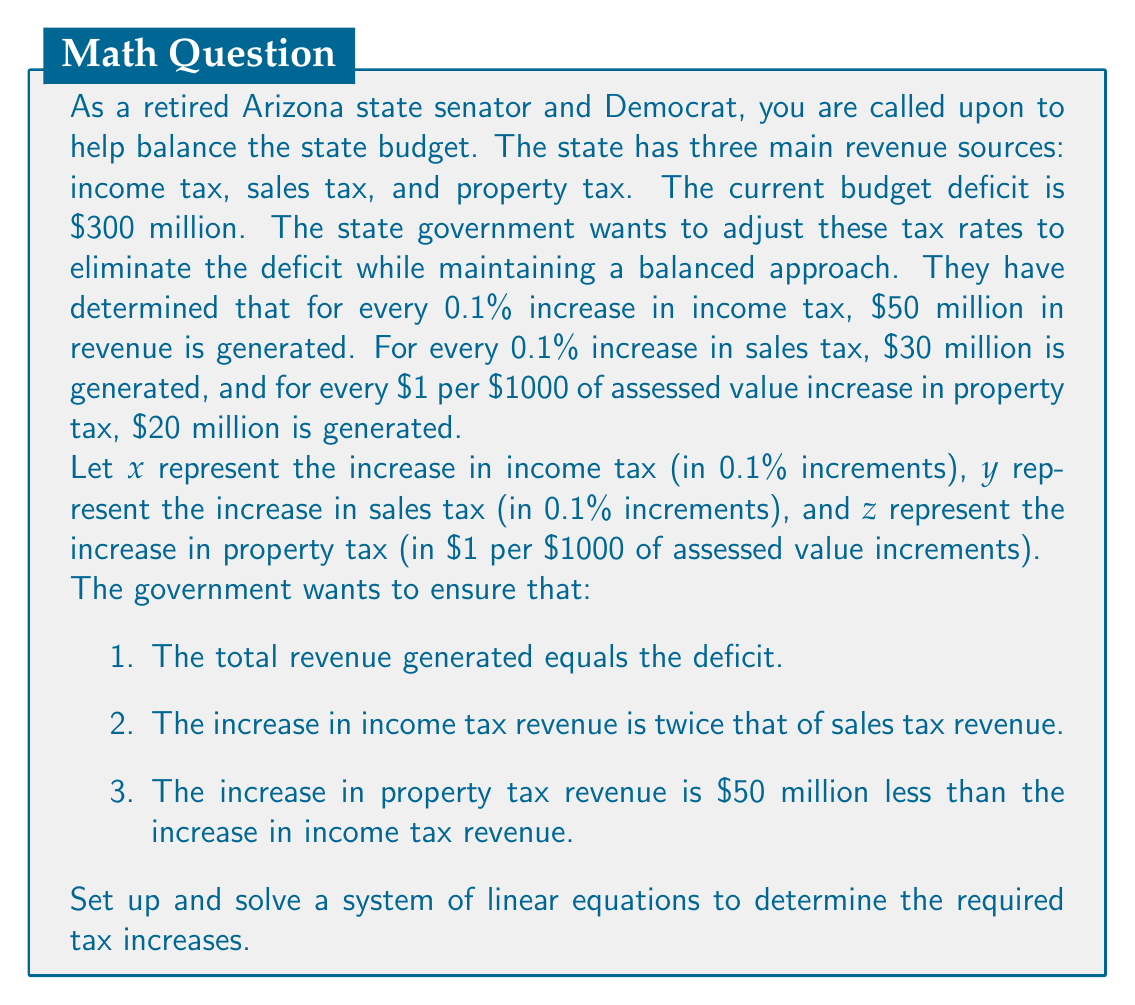What is the answer to this math problem? Let's set up the system of linear equations based on the given conditions:

1. Total revenue equals the deficit:
   $$50x + 30y + 20z = 300$$

2. Income tax revenue is twice sales tax revenue:
   $$50x = 2(30y)$$
   $$50x - 60y = 0$$

3. Property tax revenue is $50 million less than income tax revenue:
   $$20z = 50x - 50$$
   $$50x - 20z = 50$$

Now we have a system of three equations with three unknowns:

$$\begin{cases}
50x + 30y + 20z = 300 \\
50x - 60y = 0 \\
50x - 20z = 50
\end{cases}$$

Let's solve this system using elimination method:

From equation 2: $x = \frac{6}{5}y$

Substitute this into equation 3:
$$50(\frac{6}{5}y) - 20z = 50$$
$$60y - 20z = 50 \quad \text{(4)}$$

Now substitute $x = \frac{6}{5}y$ into equation 1:
$$50(\frac{6}{5}y) + 30y + 20z = 300$$
$$60y + 30y + 20z = 300$$
$$90y + 20z = 300 \quad \text{(5)}$$

Multiply equation (4) by 3 and equation (5) by -2:
$$180y - 60z = 150 \quad \text{(6)}$$
$$-180y - 40z = -600 \quad \text{(7)}$$

Add equations (6) and (7):
$$-100z = -450$$
$$z = 4.5$$

Substitute $z = 4.5$ into equation (4):
$$60y - 20(4.5) = 50$$
$$60y - 90 = 50$$
$$60y = 140$$
$$y = \frac{7}{3} \approx 2.33$$

Now we can find $x$:
$$x = \frac{6}{5}y = \frac{6}{5} \cdot \frac{7}{3} = \frac{14}{5} = 2.8$$
Answer: The required tax increases are:
Income tax: $2.8 \times 0.1\% = 0.28\%$
Sales tax: $2.33 \times 0.1\% \approx 0.23\%$
Property tax: $4.5$ per $1000 of assessed value 